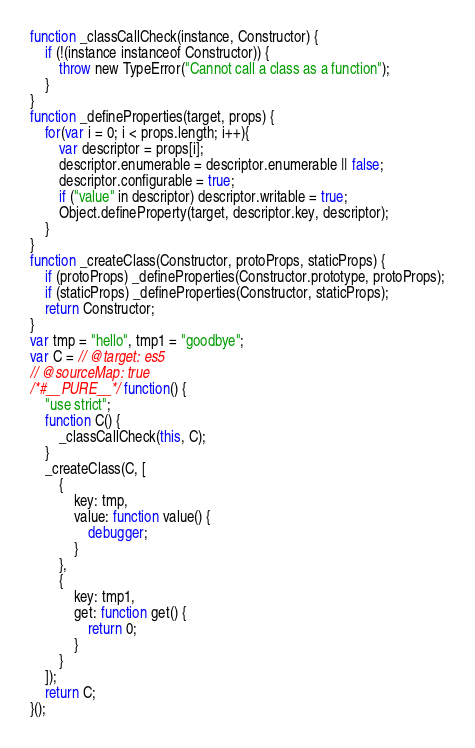Convert code to text. <code><loc_0><loc_0><loc_500><loc_500><_JavaScript_>function _classCallCheck(instance, Constructor) {
    if (!(instance instanceof Constructor)) {
        throw new TypeError("Cannot call a class as a function");
    }
}
function _defineProperties(target, props) {
    for(var i = 0; i < props.length; i++){
        var descriptor = props[i];
        descriptor.enumerable = descriptor.enumerable || false;
        descriptor.configurable = true;
        if ("value" in descriptor) descriptor.writable = true;
        Object.defineProperty(target, descriptor.key, descriptor);
    }
}
function _createClass(Constructor, protoProps, staticProps) {
    if (protoProps) _defineProperties(Constructor.prototype, protoProps);
    if (staticProps) _defineProperties(Constructor, staticProps);
    return Constructor;
}
var tmp = "hello", tmp1 = "goodbye";
var C = // @target: es5
// @sourceMap: true
/*#__PURE__*/ function() {
    "use strict";
    function C() {
        _classCallCheck(this, C);
    }
    _createClass(C, [
        {
            key: tmp,
            value: function value() {
                debugger;
            }
        },
        {
            key: tmp1,
            get: function get() {
                return 0;
            }
        }
    ]);
    return C;
}();
</code> 